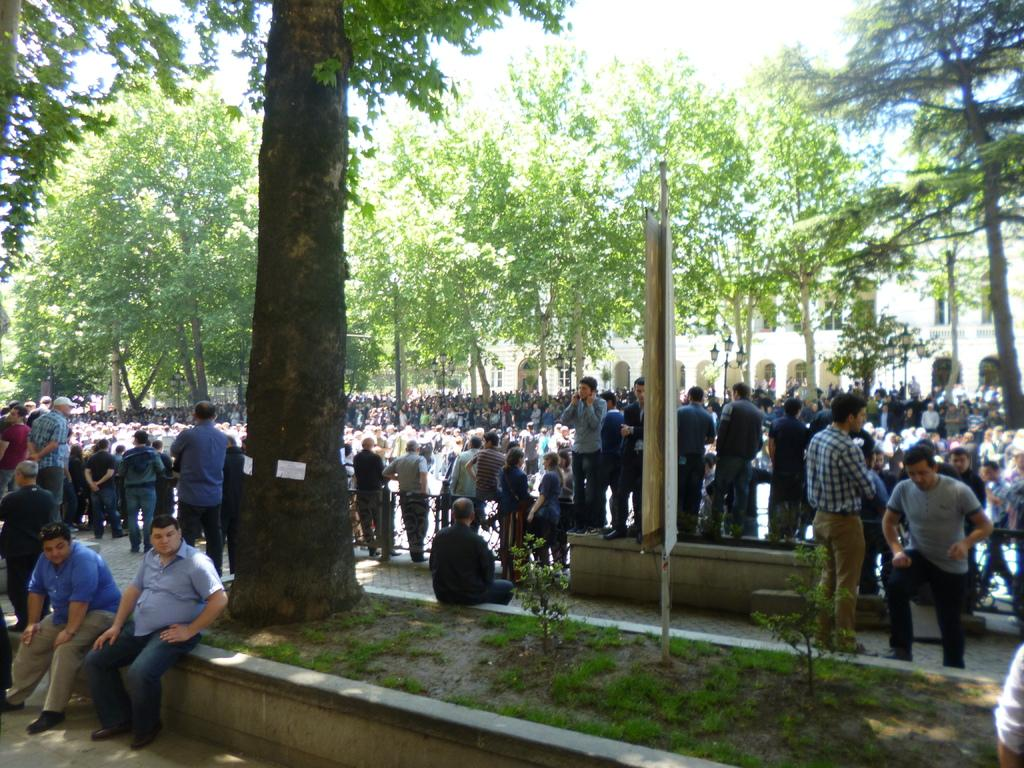How many people are in the image? There is a group of people in the image, but the exact number is not specified. What are the people in the image doing? Some people are standing, while others are sitting. What type of terrain is visible in the image? There is grass in the image. What type of barrier is present in the image? There is a fence in the image. What type of vegetation is visible in the image? There are trees in the image. What type of structure is visible in the image? There is a building with windows in the image. What is visible in the background of the image? The sky is visible in the background of the image. Where is the kettle being used in the image? There is no kettle present in the image. What type of root is growing near the fence in the image? There is no root visible in the image; only grass, trees, and a fence are present. 